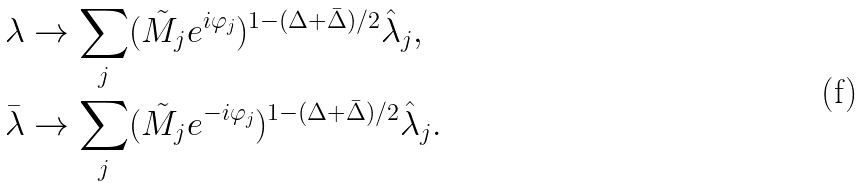<formula> <loc_0><loc_0><loc_500><loc_500>\lambda & \to \sum _ { j } ( \tilde { M } _ { j } e ^ { i \varphi _ { j } } ) ^ { 1 - ( \Delta + \bar { \Delta } ) / 2 } \hat { \lambda } _ { j } , \\ \bar { \lambda } & \to \sum _ { j } ( \tilde { M } _ { j } e ^ { - i \varphi _ { j } } ) ^ { 1 - ( \Delta + \bar { \Delta } ) / 2 } \hat { \lambda } _ { j } .</formula> 